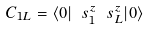Convert formula to latex. <formula><loc_0><loc_0><loc_500><loc_500>C _ { 1 L } = \langle 0 | \ s ^ { z } _ { 1 } \ s ^ { z } _ { L } | 0 \rangle</formula> 